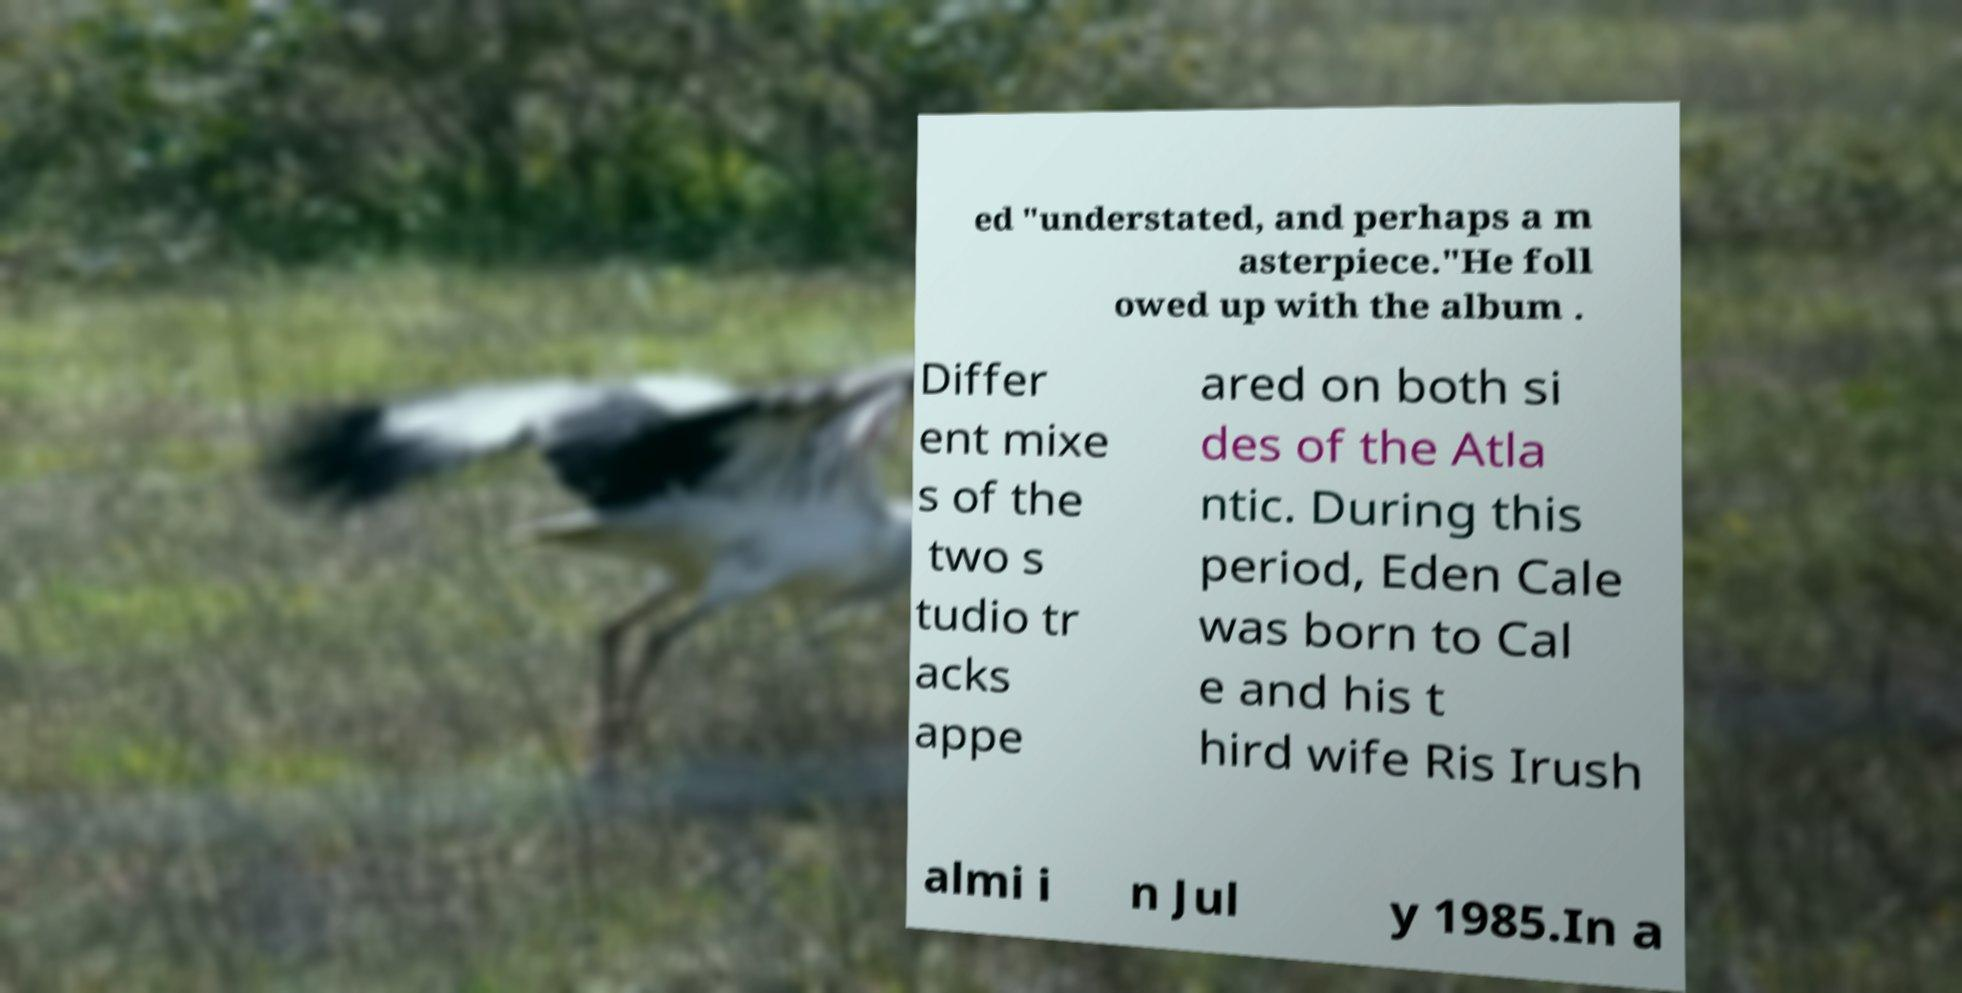I need the written content from this picture converted into text. Can you do that? ed "understated, and perhaps a m asterpiece."He foll owed up with the album . Differ ent mixe s of the two s tudio tr acks appe ared on both si des of the Atla ntic. During this period, Eden Cale was born to Cal e and his t hird wife Ris Irush almi i n Jul y 1985.In a 